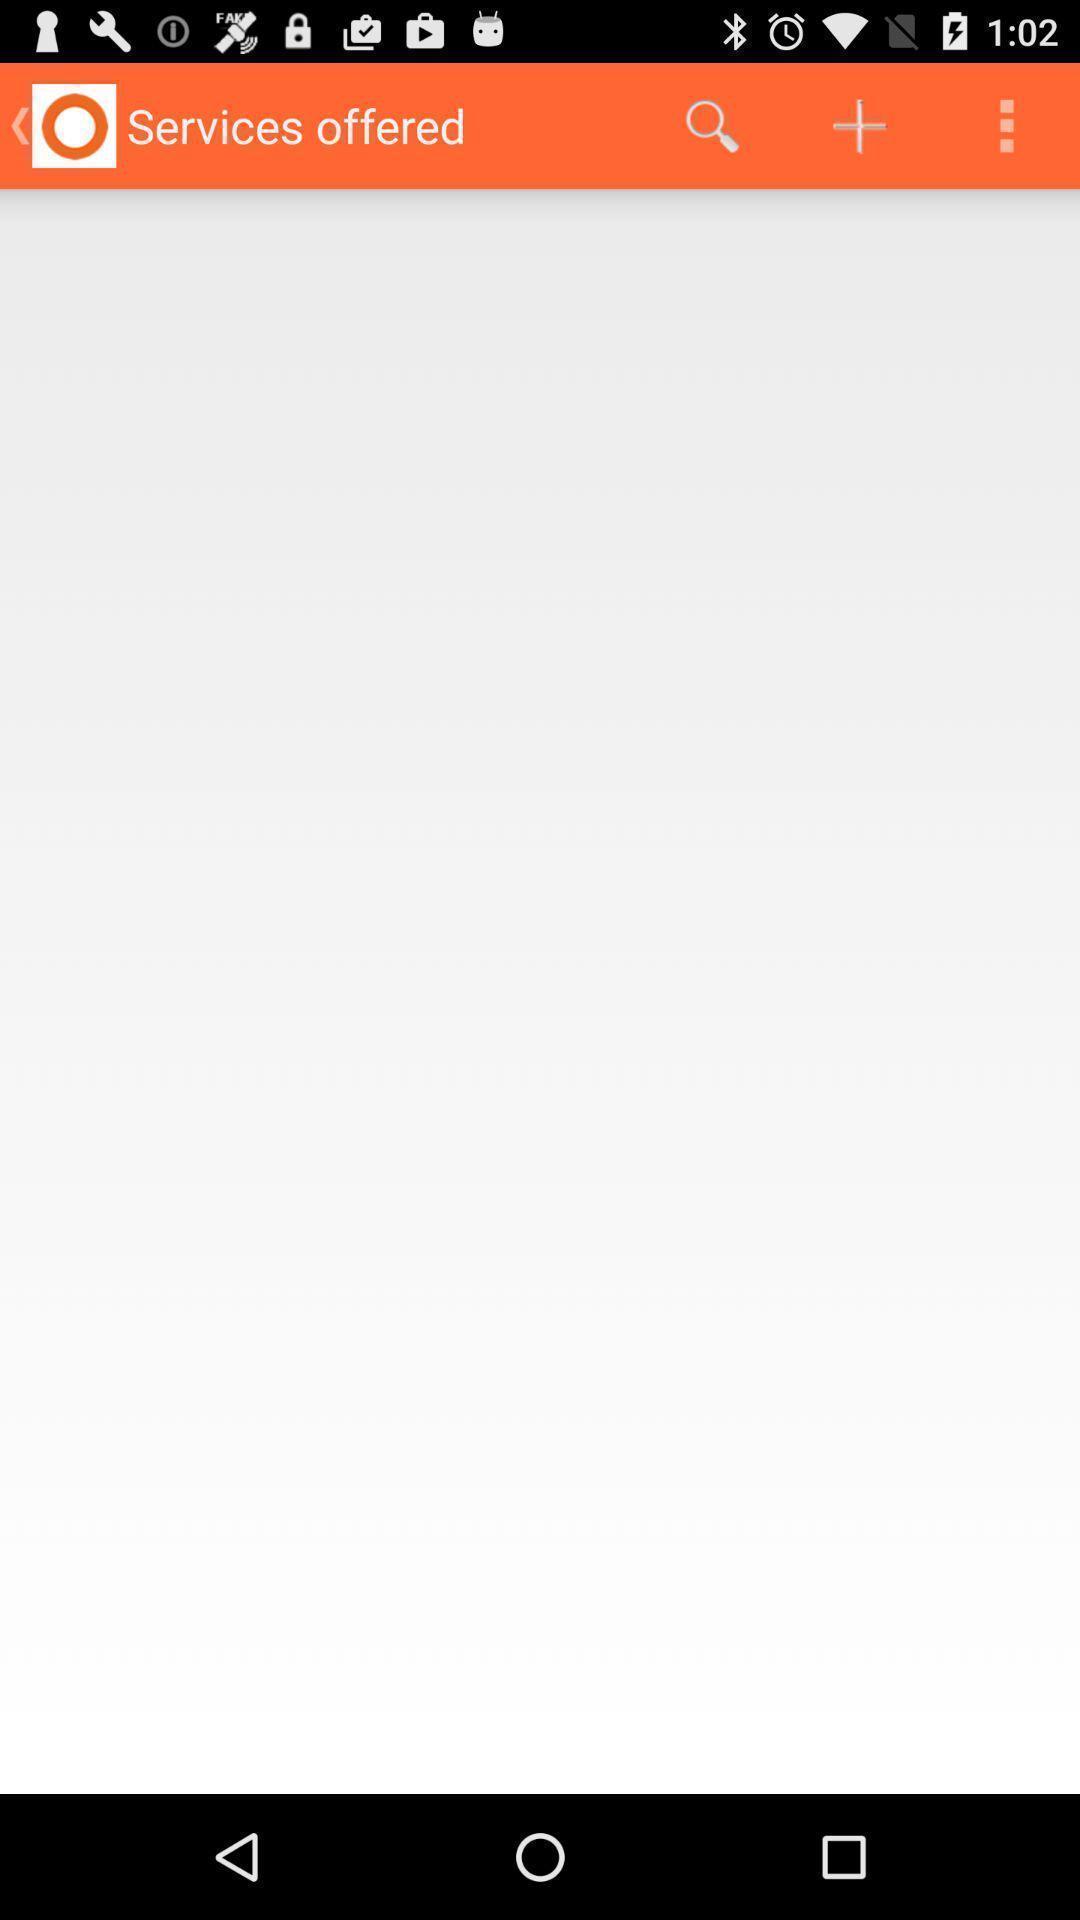Tell me what you see in this picture. Screen displaying the blank page in service offered. 